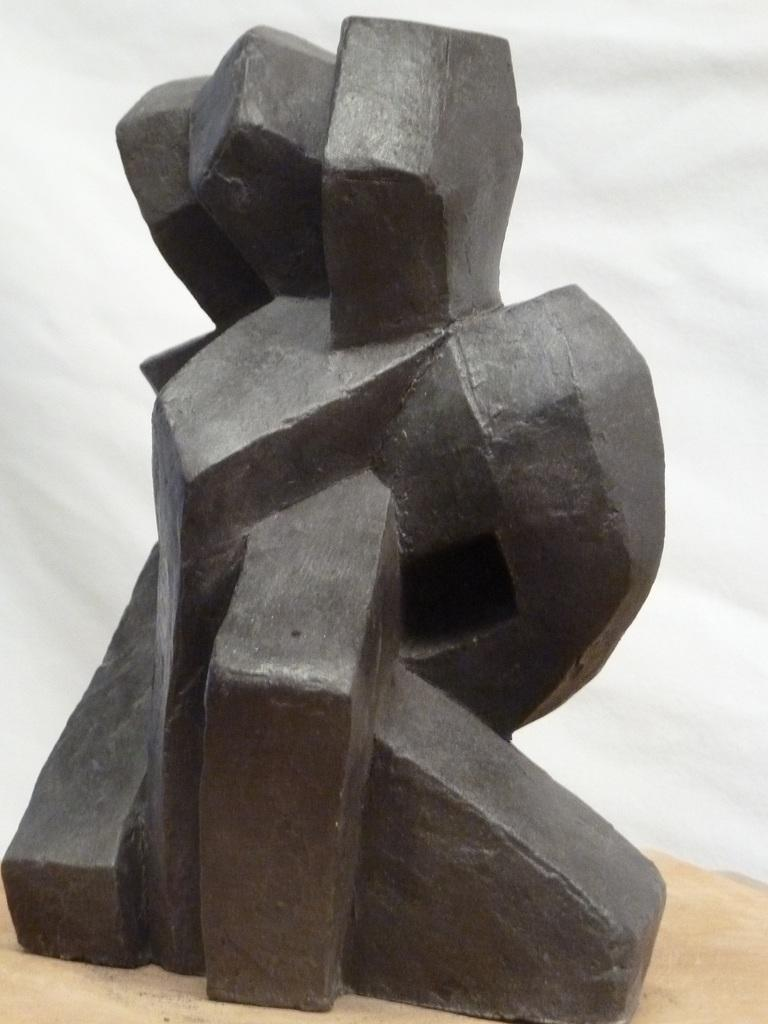What is the main subject of the image? There is a sculpture in the image. Where is the sculpture located? The sculpture is on a surface. What color is the background of the image? The background of the image is white in color. What type of polish is being applied to the sculpture in the image? There is no indication in the image that any polish is being applied to the sculpture. In which direction is the sculpture facing in the image? The image does not provide information about the direction the sculpture is facing. 